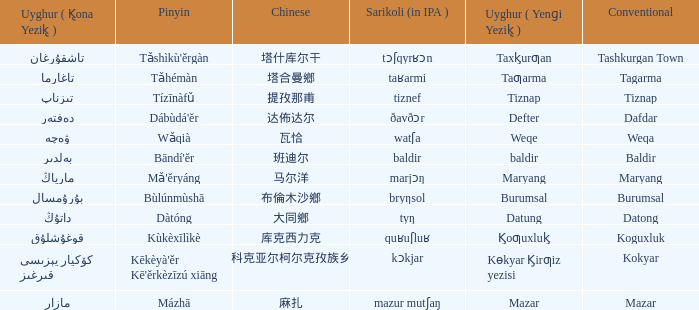Name the pinyin for تىزناپ Tízīnàfǔ. 